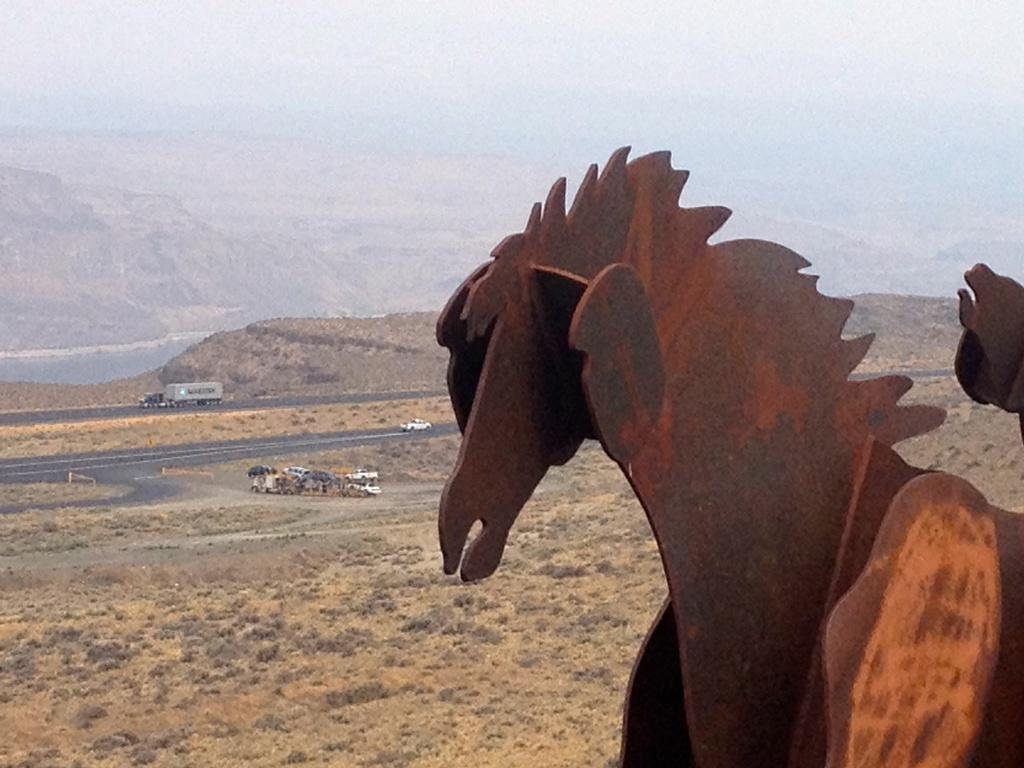What type of landscape is depicted in the image? There are hills in the image. What can be seen on the road in the image? There are vehicles on the road in the image. What is the group of people doing in the image? The group of people is not specified, but they are present in the image. What architectural elements are present in the image? There are horse statues in the image. What is visible at the top of the image? The sky is visible at the top of the image. Where is the mailbox located in the image? There is no mailbox present in the image. How are the people measuring the distance between the hills in the image? There is no indication of measuring or distance between the hills in the image. 